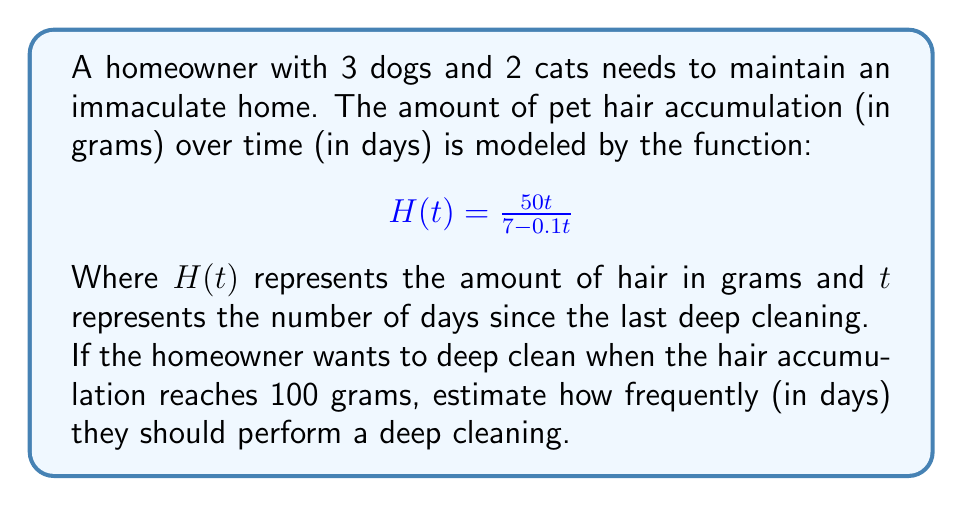Could you help me with this problem? To solve this problem, we need to find the value of $t$ when $H(t) = 100$. Let's approach this step-by-step:

1) Set up the equation:
   $$100 = \frac{50t}{7 - 0.1t}$$

2) Multiply both sides by $(7 - 0.1t)$:
   $$100(7 - 0.1t) = 50t$$

3) Expand the left side:
   $$700 - 10t = 50t$$

4) Add $10t$ to both sides:
   $$700 = 60t$$

5) Divide both sides by 60:
   $$\frac{700}{60} = t$$

6) Simplify:
   $$11.67 = t$$

Therefore, the homeowner should perform a deep cleaning approximately every 11.67 days.

To verify, we can plug this value back into the original function:

$$H(11.67) = \frac{50(11.67)}{7 - 0.1(11.67)} \approx 100.04$$

This confirms our calculation is correct (the small difference is due to rounding).
Answer: Every 11.67 days 